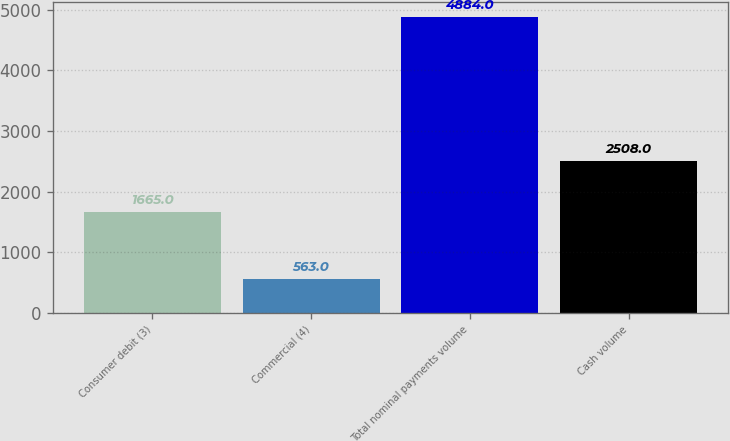Convert chart to OTSL. <chart><loc_0><loc_0><loc_500><loc_500><bar_chart><fcel>Consumer debit (3)<fcel>Commercial (4)<fcel>Total nominal payments volume<fcel>Cash volume<nl><fcel>1665<fcel>563<fcel>4884<fcel>2508<nl></chart> 